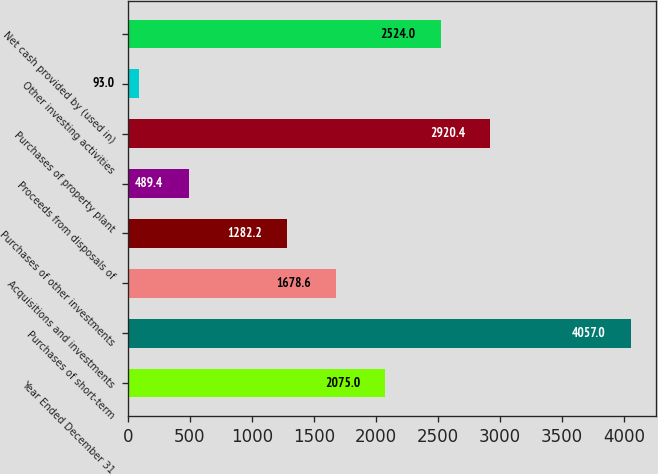<chart> <loc_0><loc_0><loc_500><loc_500><bar_chart><fcel>Year Ended December 31<fcel>Purchases of short-term<fcel>Acquisitions and investments<fcel>Purchases of other investments<fcel>Proceeds from disposals of<fcel>Purchases of property plant<fcel>Other investing activities<fcel>Net cash provided by (used in)<nl><fcel>2075<fcel>4057<fcel>1678.6<fcel>1282.2<fcel>489.4<fcel>2920.4<fcel>93<fcel>2524<nl></chart> 